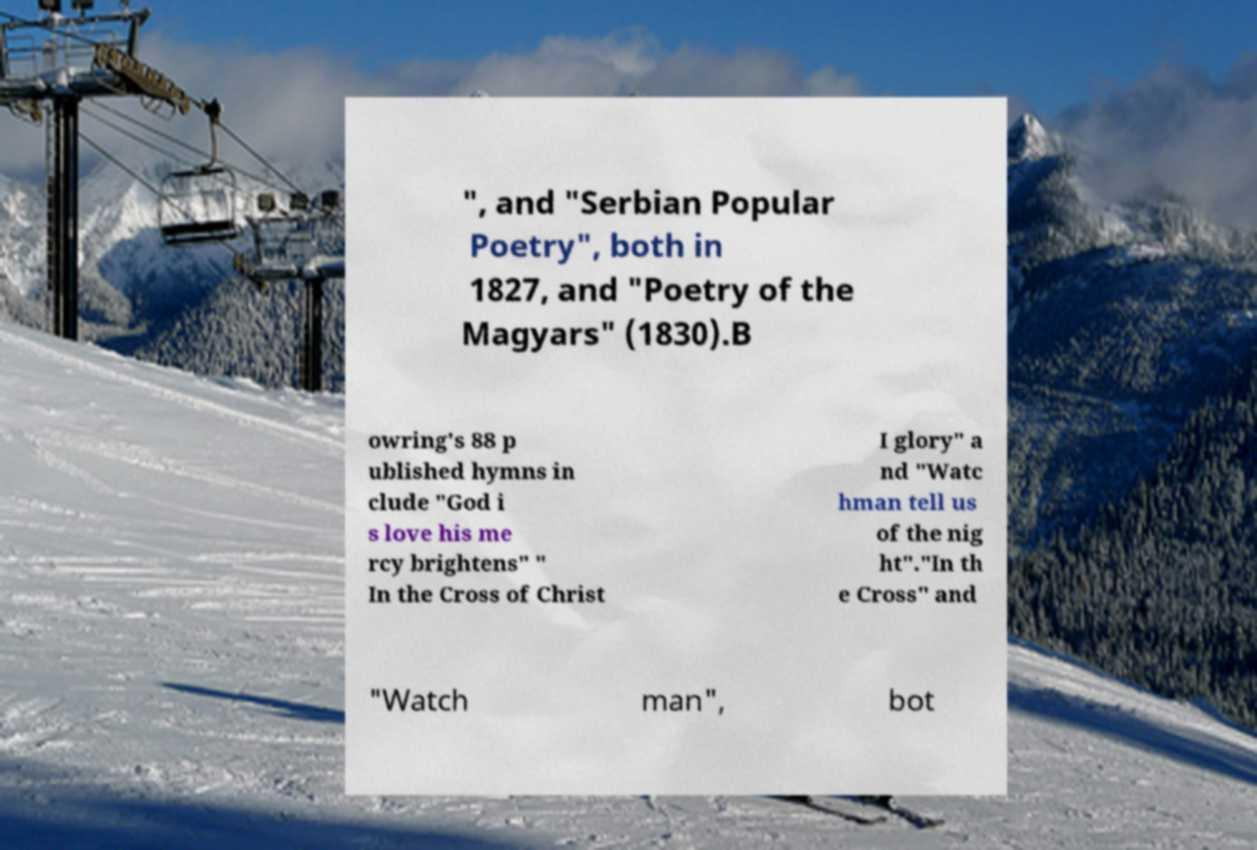What messages or text are displayed in this image? I need them in a readable, typed format. ", and "Serbian Popular Poetry", both in 1827, and "Poetry of the Magyars" (1830).B owring's 88 p ublished hymns in clude "God i s love his me rcy brightens" " In the Cross of Christ I glory" a nd "Watc hman tell us of the nig ht"."In th e Cross" and "Watch man", bot 